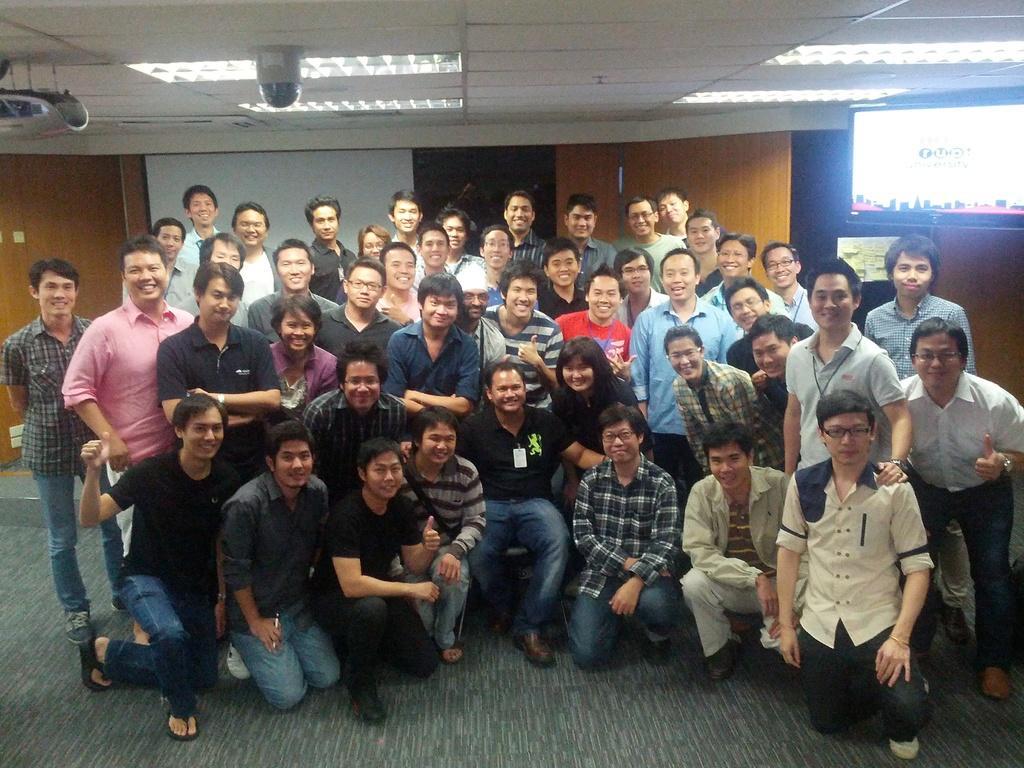Please provide a concise description of this image. In this image I can see group of people. In front the person is wearing black shirt, blue pant, background I can see a screen and I can also see the wooden wall in brown color and I can see few lights. 